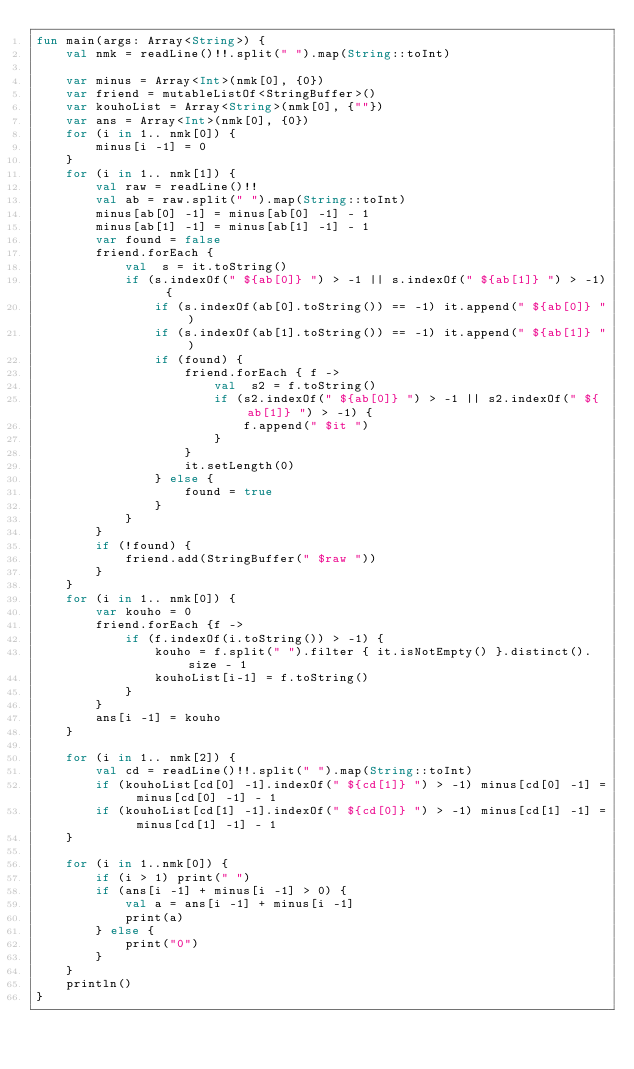Convert code to text. <code><loc_0><loc_0><loc_500><loc_500><_Kotlin_>fun main(args: Array<String>) {
    val nmk = readLine()!!.split(" ").map(String::toInt)

    var minus = Array<Int>(nmk[0], {0})
    var friend = mutableListOf<StringBuffer>()
    var kouhoList = Array<String>(nmk[0], {""})
    var ans = Array<Int>(nmk[0], {0})
    for (i in 1.. nmk[0]) {
        minus[i -1] = 0
    }
    for (i in 1.. nmk[1]) {
        val raw = readLine()!!
        val ab = raw.split(" ").map(String::toInt)
        minus[ab[0] -1] = minus[ab[0] -1] - 1
        minus[ab[1] -1] = minus[ab[1] -1] - 1
        var found = false
        friend.forEach {
            val  s = it.toString()
            if (s.indexOf(" ${ab[0]} ") > -1 || s.indexOf(" ${ab[1]} ") > -1) {
                if (s.indexOf(ab[0].toString()) == -1) it.append(" ${ab[0]} ")
                if (s.indexOf(ab[1].toString()) == -1) it.append(" ${ab[1]} ")
                if (found) {
                    friend.forEach { f ->
                        val  s2 = f.toString()
                        if (s2.indexOf(" ${ab[0]} ") > -1 || s2.indexOf(" ${ab[1]} ") > -1) {
                            f.append(" $it ")
                        }
                    }
                    it.setLength(0)
                } else {
                    found = true
                }
            }
        }
        if (!found) {
            friend.add(StringBuffer(" $raw "))
        }
    }
    for (i in 1.. nmk[0]) {
        var kouho = 0
        friend.forEach {f ->
            if (f.indexOf(i.toString()) > -1) {
                kouho = f.split(" ").filter { it.isNotEmpty() }.distinct().size - 1
                kouhoList[i-1] = f.toString()
            }
        }
        ans[i -1] = kouho
    }

    for (i in 1.. nmk[2]) {
        val cd = readLine()!!.split(" ").map(String::toInt)
        if (kouhoList[cd[0] -1].indexOf(" ${cd[1]} ") > -1) minus[cd[0] -1] = minus[cd[0] -1] - 1
        if (kouhoList[cd[1] -1].indexOf(" ${cd[0]} ") > -1) minus[cd[1] -1] = minus[cd[1] -1] - 1
    }

    for (i in 1..nmk[0]) {
        if (i > 1) print(" ")
        if (ans[i -1] + minus[i -1] > 0) {
            val a = ans[i -1] + minus[i -1]
            print(a)
        } else {
            print("0")
        }
    }
    println()
}
</code> 